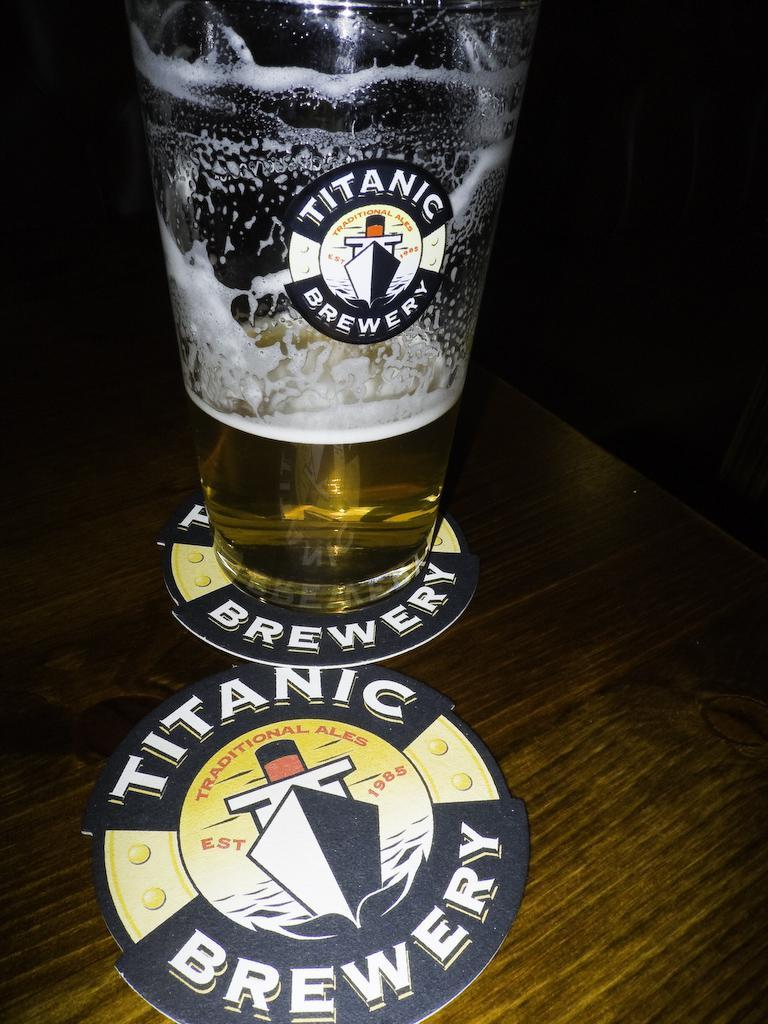<image>
Describe the image concisely. A glass and two coasters with Titanic Brewery on the label. 